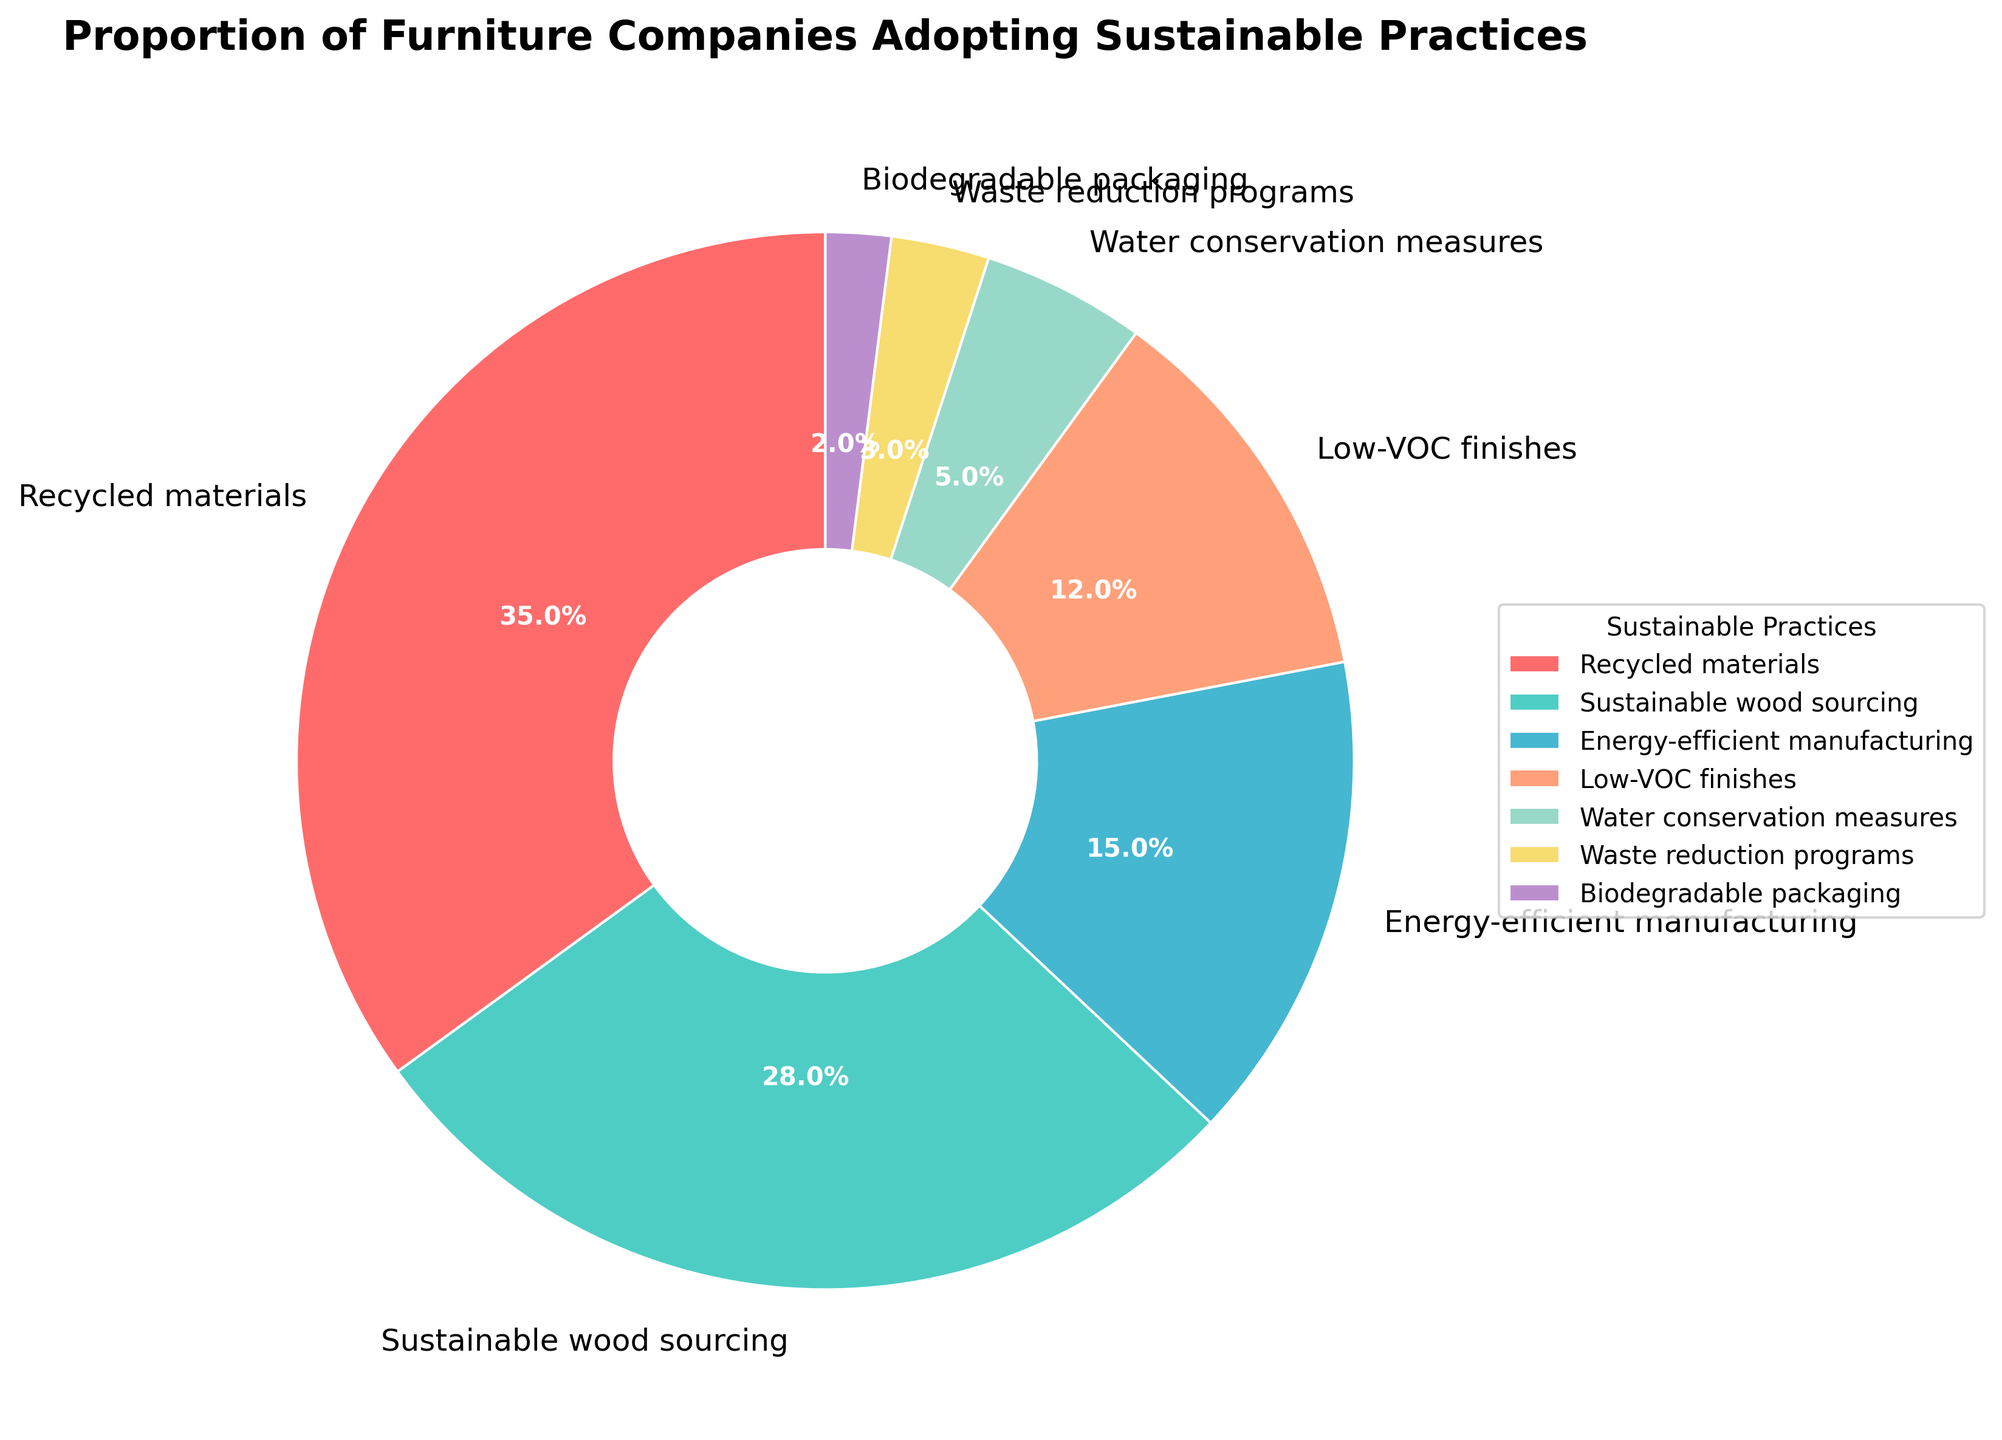What is the largest proportion of sustainable practices adopted by furniture companies? By looking at the visual slices of the pie chart, the category with the largest proportion can be observed. The "Recycled materials" slice is the largest, indicating it has the highest proportion.
Answer: Recycled materials Which sustainable practice is adopted by the smallest proportion of furniture companies? Observing the smallest slice of the pie chart reveals the least adopted practice. The "Biodegradable packaging" slice is the smallest.
Answer: Biodegradable packaging What is the combined proportion of companies adopting energy-efficient manufacturing and low-VOC finishes? To find the combined proportion, add the percentages of the two categories: 15% (Energy-efficient manufacturing) + 12% (Low-VOC finishes). 15 + 12 = 27
Answer: 27% How does the proportion of companies adopting sustainable wood sourcing compare to those adopting water conservation measures? Compare the sizes of the "Sustainable wood sourcing" and "Water conservation measures" slices. Sustainable wood sourcing is 28%, and water conservation measures is 5%. 28 is significantly larger than 5.
Answer: Sustainable wood sourcing is greater Which practice is shown with the red slice in the pie chart? Identify the red slice visually in the pie chart. The category associated with the red slice is "Recycled materials".
Answer: Recycled materials What is the percentage difference between companies adopting recycled materials and those adopting sustainable wood sourcing? The percentage for recycled materials is 35% and for sustainable wood sourcing is 28%. Subtracting 28 from 35 gives the difference. 35 - 28 = 7
Answer: 7% What is the second most adopted sustainable practice? After Recycled materials which is the most adopted at 35%, the next largest slice is Sustainable wood sourcing at 28%.
Answer: Sustainable wood sourcing What proportion of companies adopt practices related to waste management (waste reduction programs and biodegradable packaging combined)? Add the percentages of waste reduction programs (3%) and biodegradable packaging (2%). 3 + 2 = 5
Answer: 5% What is the average percentage of adoption for low-VOC finishes and water conservation measures? To find the average, add the percentages of low-VOC finishes (12%) and water conservation measures (5%) and divide by 2. (12 + 5) / 2 = 17 / 2 = 8.5
Answer: 8.5% By how much is the proportion of companies adopting energy-efficient manufacturing greater than those adopting biodegradable packaging? The percentage for energy-efficient manufacturing is 15% and for biodegradable packaging is 2%. Subtracting 2 from 15 gives the difference. 15 - 2 = 13
Answer: 13% 